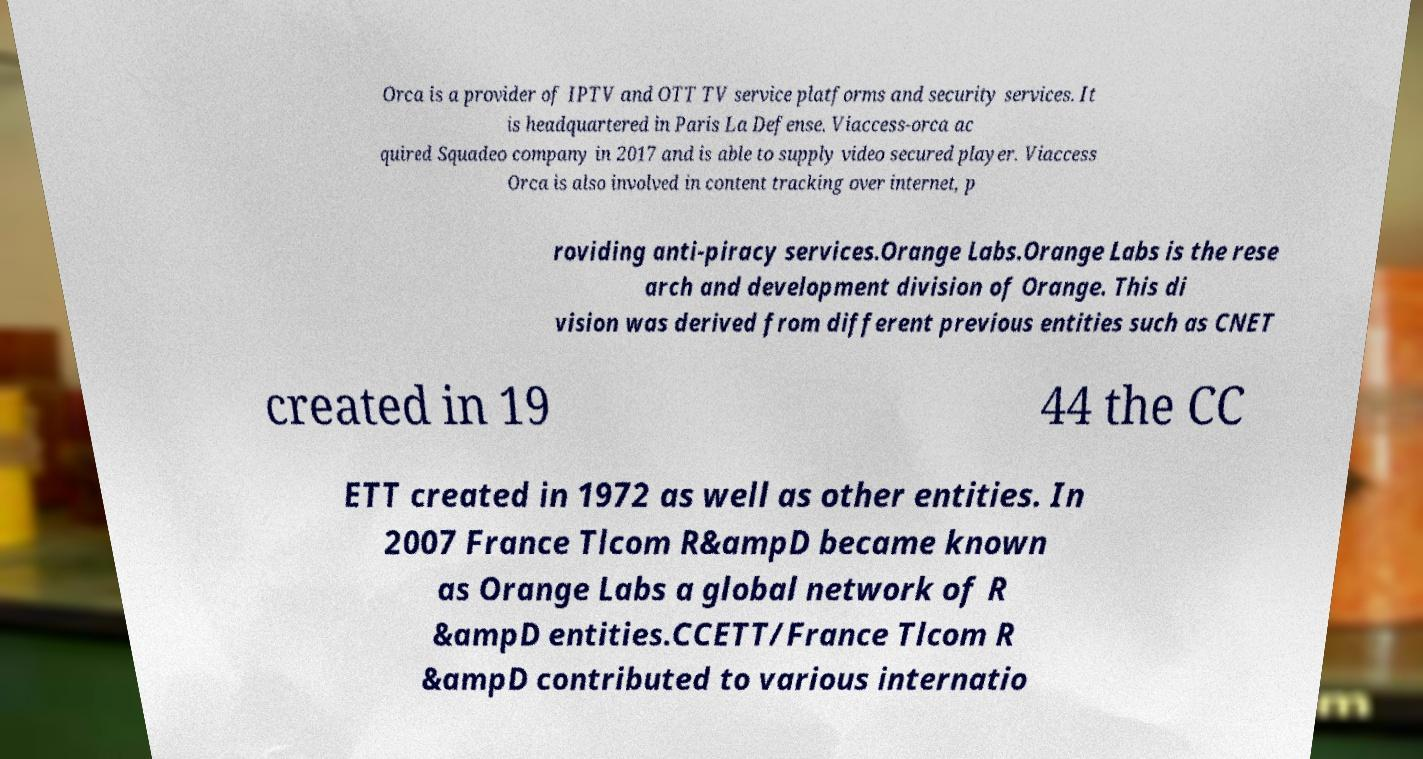Can you read and provide the text displayed in the image?This photo seems to have some interesting text. Can you extract and type it out for me? Orca is a provider of IPTV and OTT TV service platforms and security services. It is headquartered in Paris La Defense. Viaccess-orca ac quired Squadeo company in 2017 and is able to supply video secured player. Viaccess Orca is also involved in content tracking over internet, p roviding anti-piracy services.Orange Labs.Orange Labs is the rese arch and development division of Orange. This di vision was derived from different previous entities such as CNET created in 19 44 the CC ETT created in 1972 as well as other entities. In 2007 France Tlcom R&ampD became known as Orange Labs a global network of R &ampD entities.CCETT/France Tlcom R &ampD contributed to various internatio 